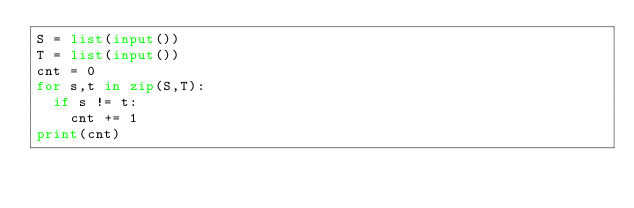Convert code to text. <code><loc_0><loc_0><loc_500><loc_500><_Python_>S = list(input())
T = list(input())
cnt = 0
for s,t in zip(S,T):
  if s != t:
    cnt += 1
print(cnt)</code> 